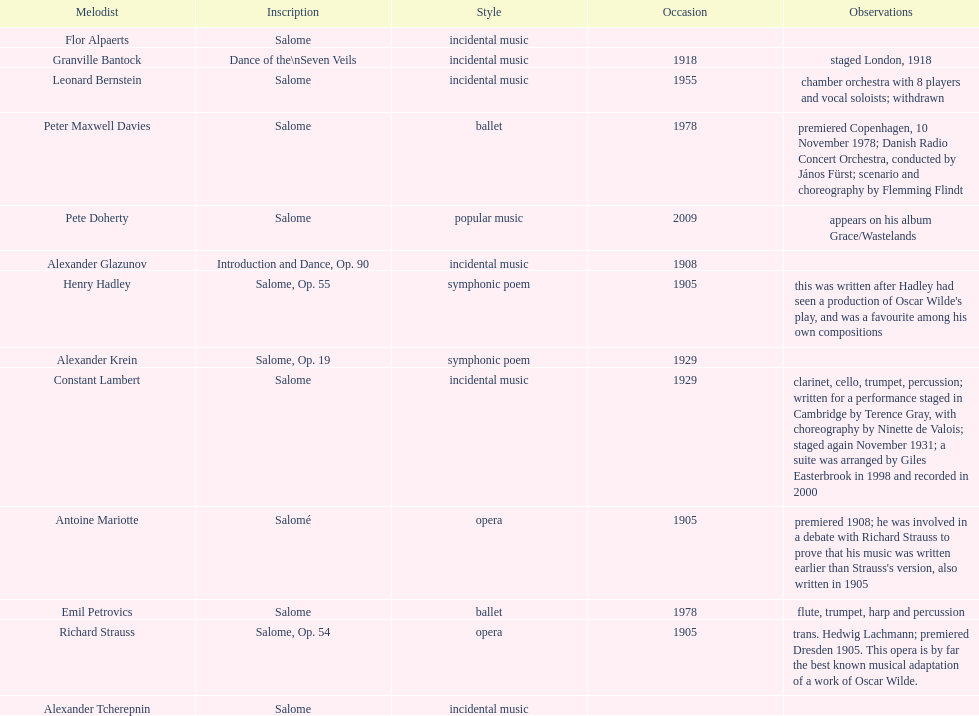Which composer produced his title after 2001? Pete Doherty. 